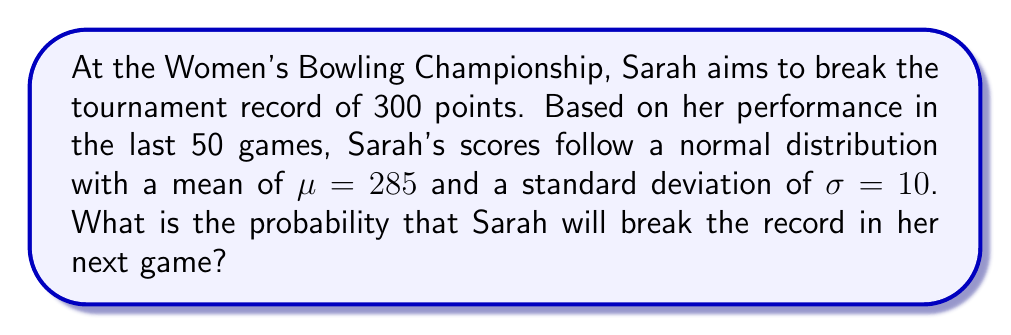Can you solve this math problem? To solve this problem, we need to follow these steps:

1) We're looking for the probability that Sarah's score (X) will exceed 300 points.
   $P(X > 300)$

2) For a normal distribution, we can standardize the score using the z-score formula:
   $z = \frac{x - \mu}{\sigma}$

3) Substituting the values:
   $z = \frac{300 - 285}{10} = 1.5$

4) Now, we need to find $P(Z > 1.5)$, where Z is the standard normal variable.

5) Using a standard normal table or calculator, we can find that:
   $P(Z < 1.5) \approx 0.9332$

6) Since we want the probability of exceeding 300, we need:
   $P(Z > 1.5) = 1 - P(Z < 1.5) = 1 - 0.9332 = 0.0668$

Therefore, the probability of Sarah breaking the record in her next game is approximately 0.0668 or 6.68%.
Answer: $0.0668$ or $6.68\%$ 